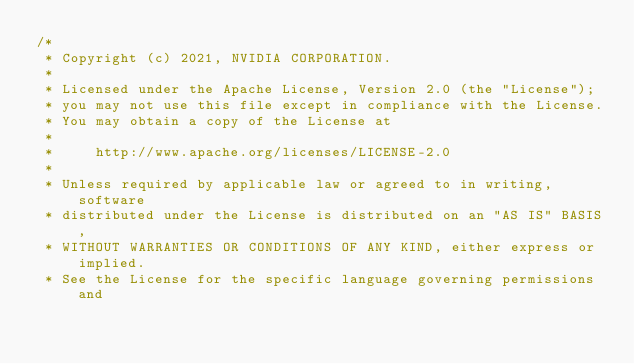<code> <loc_0><loc_0><loc_500><loc_500><_Cuda_>/*
 * Copyright (c) 2021, NVIDIA CORPORATION.
 *
 * Licensed under the Apache License, Version 2.0 (the "License");
 * you may not use this file except in compliance with the License.
 * You may obtain a copy of the License at
 *
 *     http://www.apache.org/licenses/LICENSE-2.0
 *
 * Unless required by applicable law or agreed to in writing, software
 * distributed under the License is distributed on an "AS IS" BASIS,
 * WITHOUT WARRANTIES OR CONDITIONS OF ANY KIND, either express or implied.
 * See the License for the specific language governing permissions and</code> 